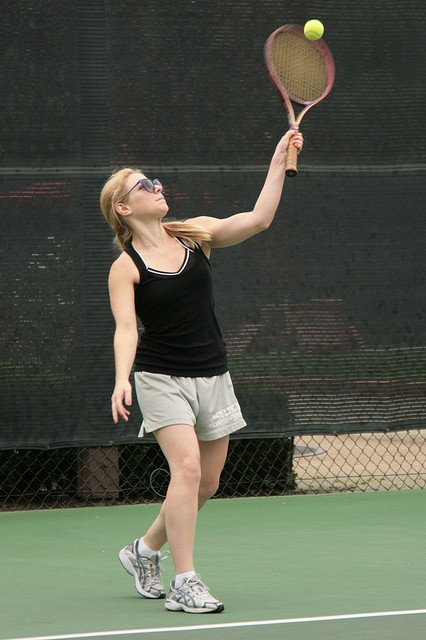Describe the objects in this image and their specific colors. I can see people in black, tan, and darkgray tones, tennis racket in black, gray, and tan tones, and sports ball in black, khaki, and olive tones in this image. 